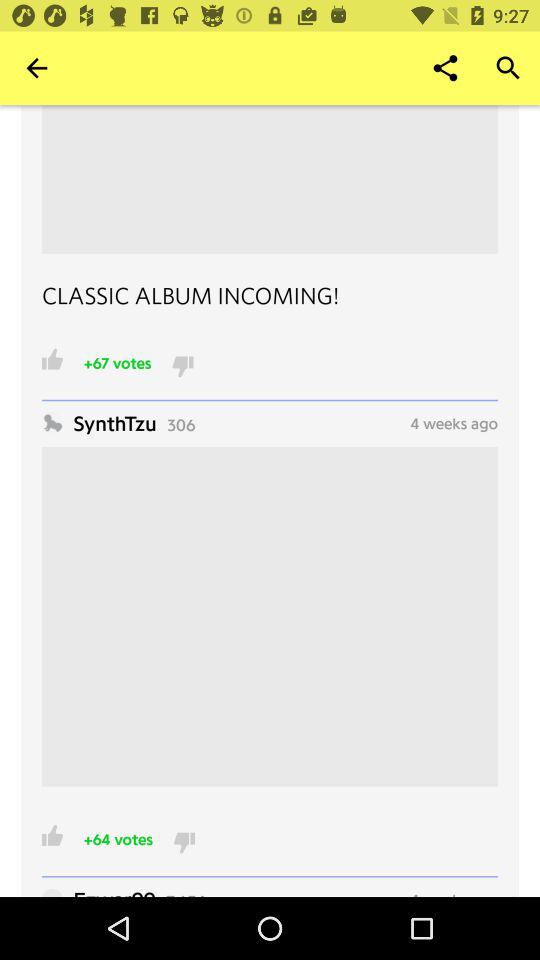What is the username? The username is "SynthTzu". 